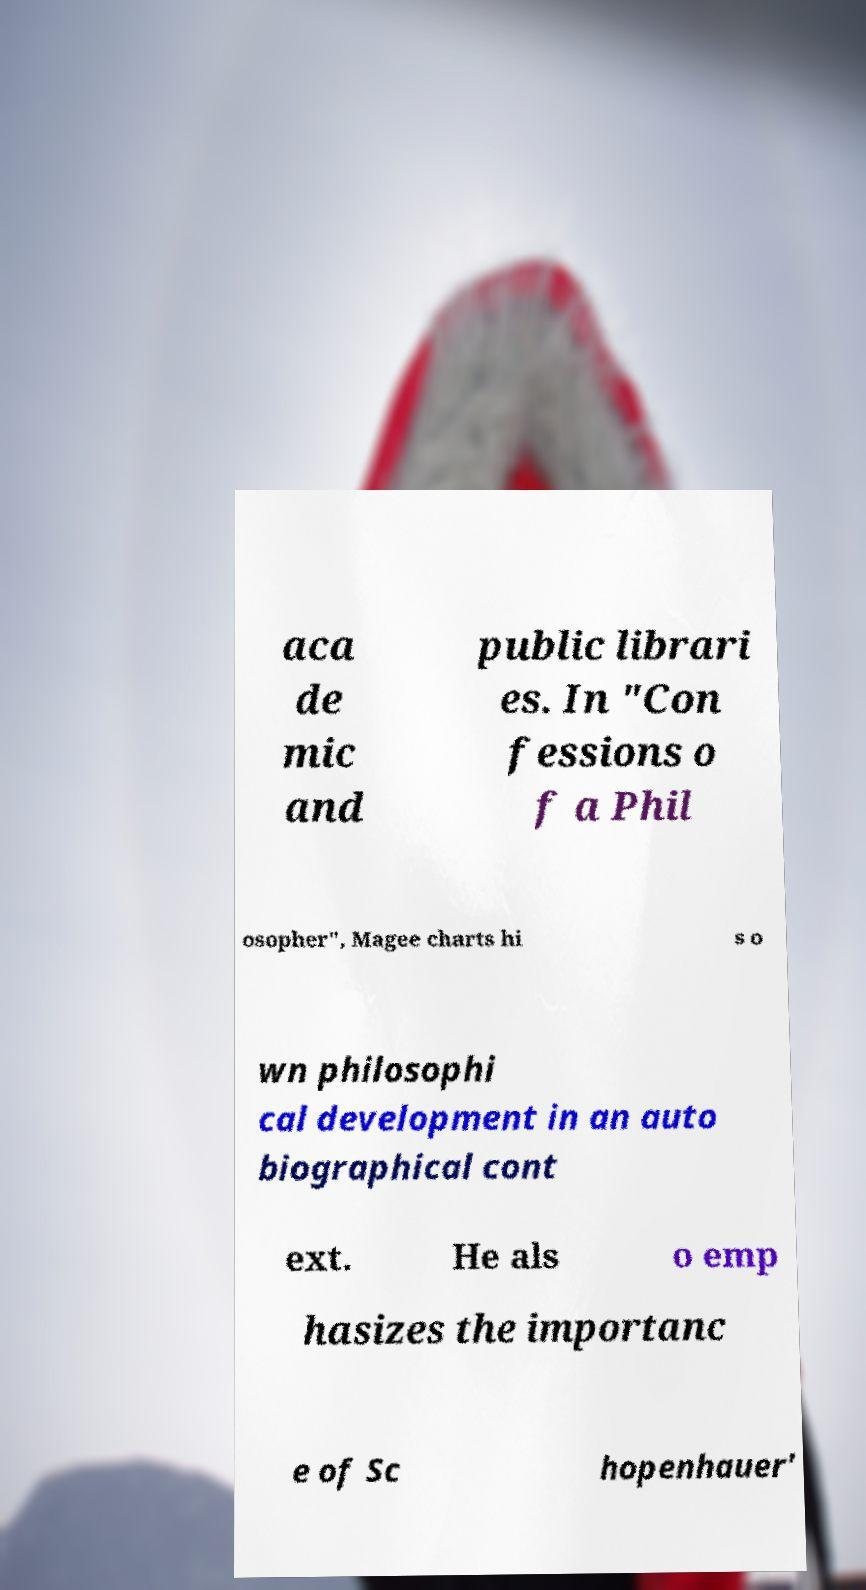I need the written content from this picture converted into text. Can you do that? aca de mic and public librari es. In "Con fessions o f a Phil osopher", Magee charts hi s o wn philosophi cal development in an auto biographical cont ext. He als o emp hasizes the importanc e of Sc hopenhauer' 